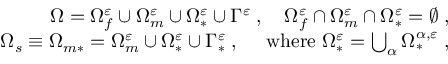<formula> <loc_0><loc_0><loc_500><loc_500>\begin{array} { r } { \Omega = \Omega _ { f } ^ { \varepsilon } \cup \Omega _ { m } ^ { \varepsilon } \cup \Omega _ { * } ^ { \varepsilon } \cup \Gamma ^ { \varepsilon } \, , \quad \Omega _ { f } ^ { \varepsilon } \cap \Omega _ { m } ^ { \varepsilon } \cap \Omega _ { * } ^ { \varepsilon } = \emptyset \, , } \\ { \Omega _ { s } \equiv \Omega _ { m * } = \Omega _ { m } ^ { \varepsilon } \cup \Omega _ { * } ^ { \varepsilon } \cup \Gamma _ { * } ^ { \varepsilon } \, , \quad w h e r e \Omega _ { * } ^ { \varepsilon } = \bigcup _ { \alpha } \Omega _ { * } ^ { { \alpha } , \varepsilon } \, , } \end{array}</formula> 